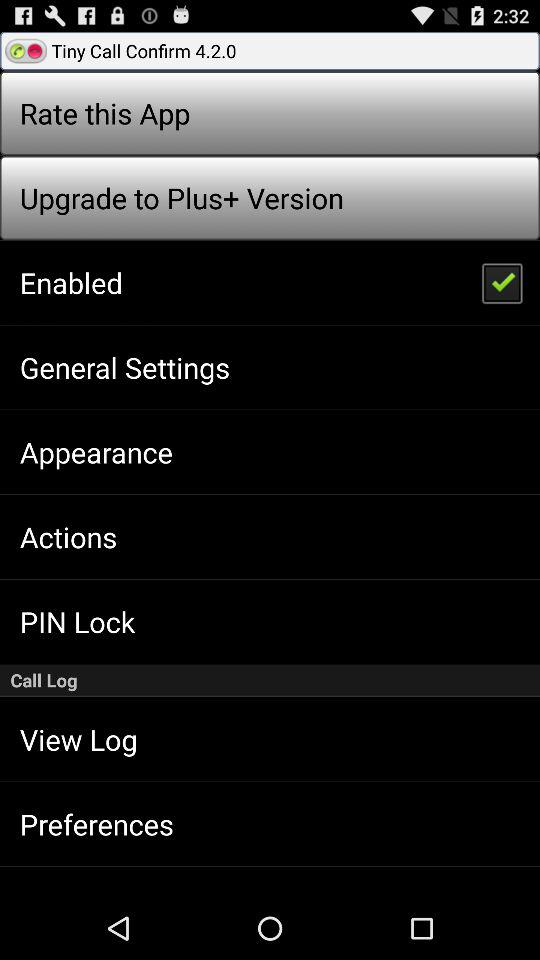What is the status of "Enabled"? The status is "on". 